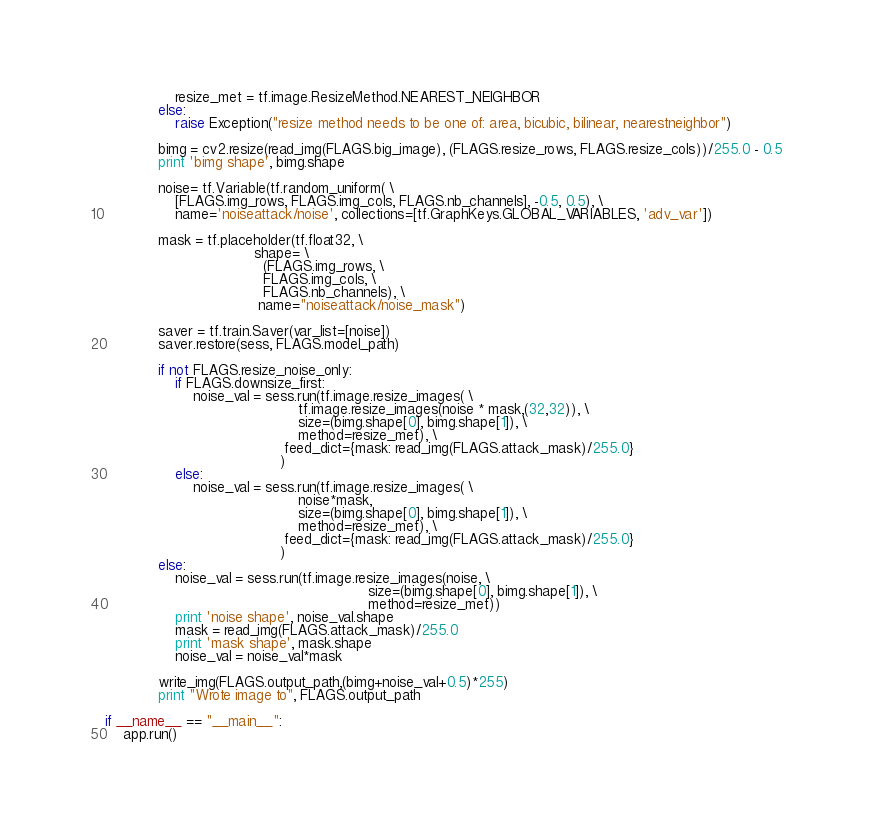<code> <loc_0><loc_0><loc_500><loc_500><_Python_>                resize_met = tf.image.ResizeMethod.NEAREST_NEIGHBOR
            else:
                raise Exception("resize method needs to be one of: area, bicubic, bilinear, nearestneighbor")

            bimg = cv2.resize(read_img(FLAGS.big_image), (FLAGS.resize_rows, FLAGS.resize_cols))/255.0 - 0.5
            print 'bimg shape', bimg.shape

            noise= tf.Variable(tf.random_uniform( \
                [FLAGS.img_rows, FLAGS.img_cols, FLAGS.nb_channels], -0.5, 0.5), \
                name='noiseattack/noise', collections=[tf.GraphKeys.GLOBAL_VARIABLES, 'adv_var'])

            mask = tf.placeholder(tf.float32, \
                                  shape= \
                                    (FLAGS.img_rows, \
                                    FLAGS.img_cols, \
                                    FLAGS.nb_channels), \
                                   name="noiseattack/noise_mask")

            saver = tf.train.Saver(var_list=[noise])
            saver.restore(sess, FLAGS.model_path)

            if not FLAGS.resize_noise_only:
                if FLAGS.downsize_first:
                    noise_val = sess.run(tf.image.resize_images( \
                                            tf.image.resize_images(noise * mask,(32,32)), \
                                            size=(bimg.shape[0], bimg.shape[1]), \
                                            method=resize_met), \
                                         feed_dict={mask: read_img(FLAGS.attack_mask)/255.0}
                                        )
                else:
                    noise_val = sess.run(tf.image.resize_images( \
                                            noise*mask,
                                            size=(bimg.shape[0], bimg.shape[1]), \
                                            method=resize_met), \
                                         feed_dict={mask: read_img(FLAGS.attack_mask)/255.0}
                                        )
            else:
                noise_val = sess.run(tf.image.resize_images(noise, \
                                                            size=(bimg.shape[0], bimg.shape[1]), \
                                                            method=resize_met))
                print 'noise shape', noise_val.shape
                mask = read_img(FLAGS.attack_mask)/255.0
                print 'mask shape', mask.shape
                noise_val = noise_val*mask

            write_img(FLAGS.output_path,(bimg+noise_val+0.5)*255)
            print "Wrote image to", FLAGS.output_path

if __name__ == "__main__":
    app.run()


</code> 